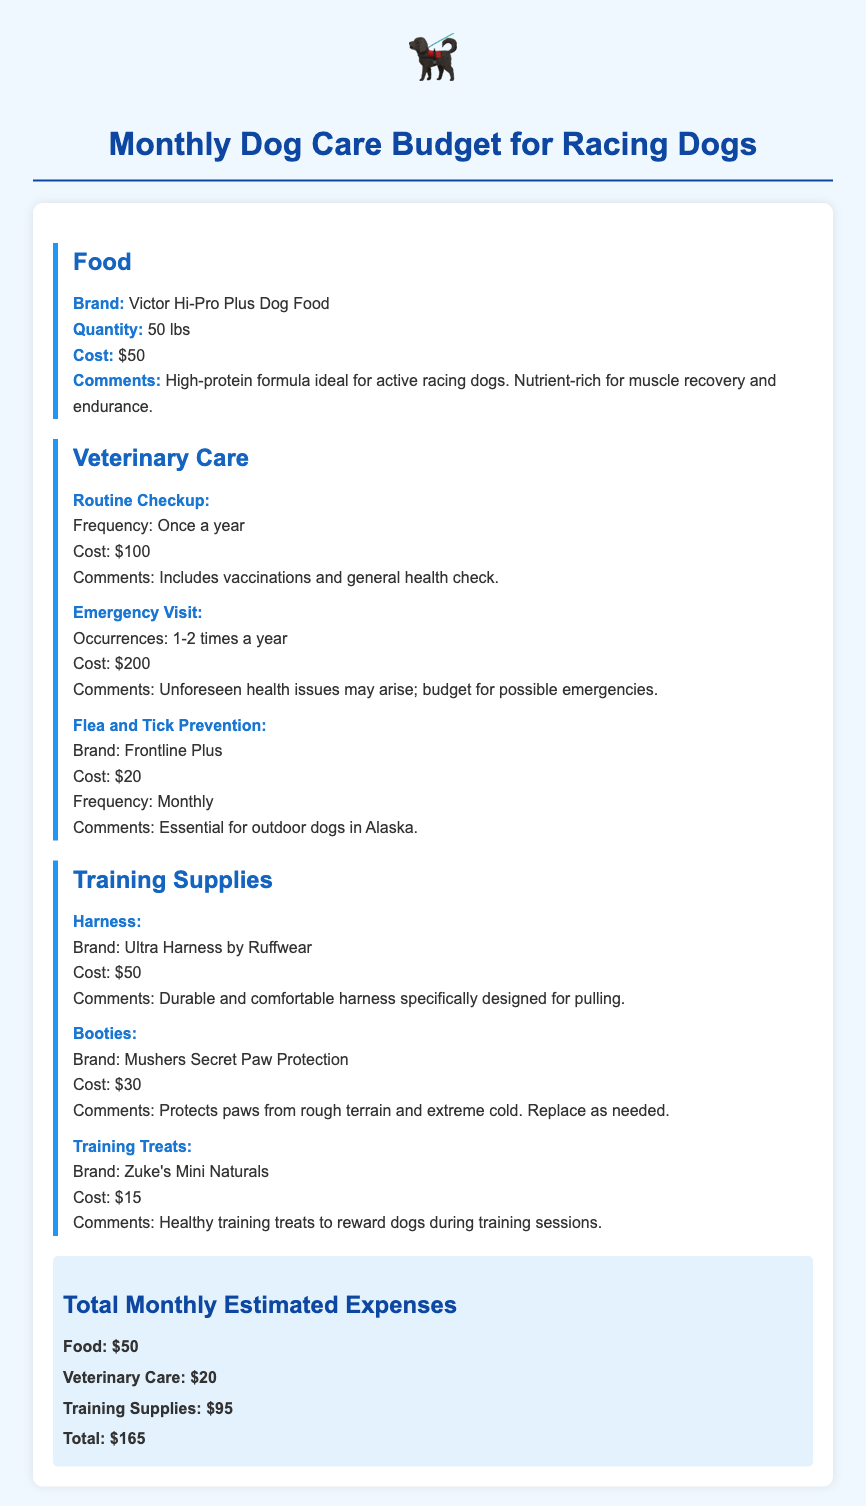What is the cost of the dog food? The cost of the Victor Hi-Pro Plus Dog Food is mentioned under the food section, which is $50.
Answer: $50 How often is the flea and tick prevention applied? The document specifies that flea and tick prevention is applied monthly under the veterinary care section.
Answer: Monthly What is the total estimated monthly expense? The total budget for monthly expenses is found at the bottom of the document, calculated as $165.
Answer: $165 Which brand of harness is recommended? The document lists the Ultra Harness by Ruffwear as the recommended harness in the training supplies section.
Answer: Ultra Harness by Ruffwear What is included in the routine checkup? The routine checkup includes vaccinations and general health check as stated in the veterinary care section.
Answer: Vaccinations and general health check How much does an emergency vet visit cost? The document states that the cost for an emergency visit is $200 under the veterinary care category.
Answer: $200 What type of treats are listed for training? The document mentions Zuke's Mini Naturals as the type of training treats provided under training supplies.
Answer: Zuke's Mini Naturals How many pounds of dog food are purchased monthly? The monthly quantity of the Victor Hi-Pro Plus Dog Food is 50 lbs, as indicated in the food section.
Answer: 50 lbs 